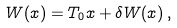<formula> <loc_0><loc_0><loc_500><loc_500>W ( x ) = T _ { 0 } x + \delta W ( x ) \, ,</formula> 